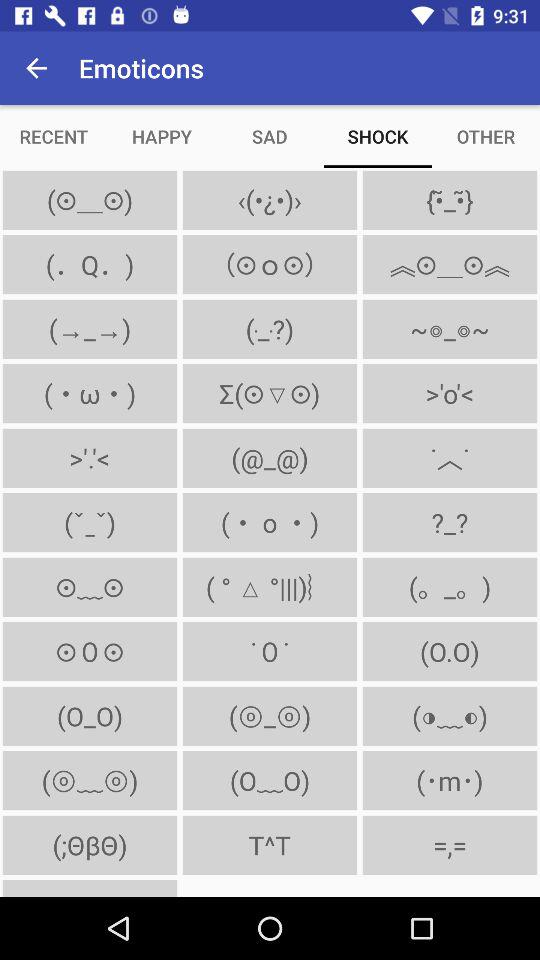Which tab has been selected? The selected tab is "SHOCK". 